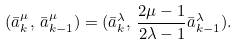Convert formula to latex. <formula><loc_0><loc_0><loc_500><loc_500>( \bar { a } _ { k } ^ { \mu } , \, \bar { a } _ { k - 1 } ^ { \mu } ) = ( \bar { a } _ { k } ^ { \lambda } , \, \frac { 2 \mu - 1 } { 2 \lambda - 1 } \bar { a } _ { k - 1 } ^ { \lambda } ) .</formula> 